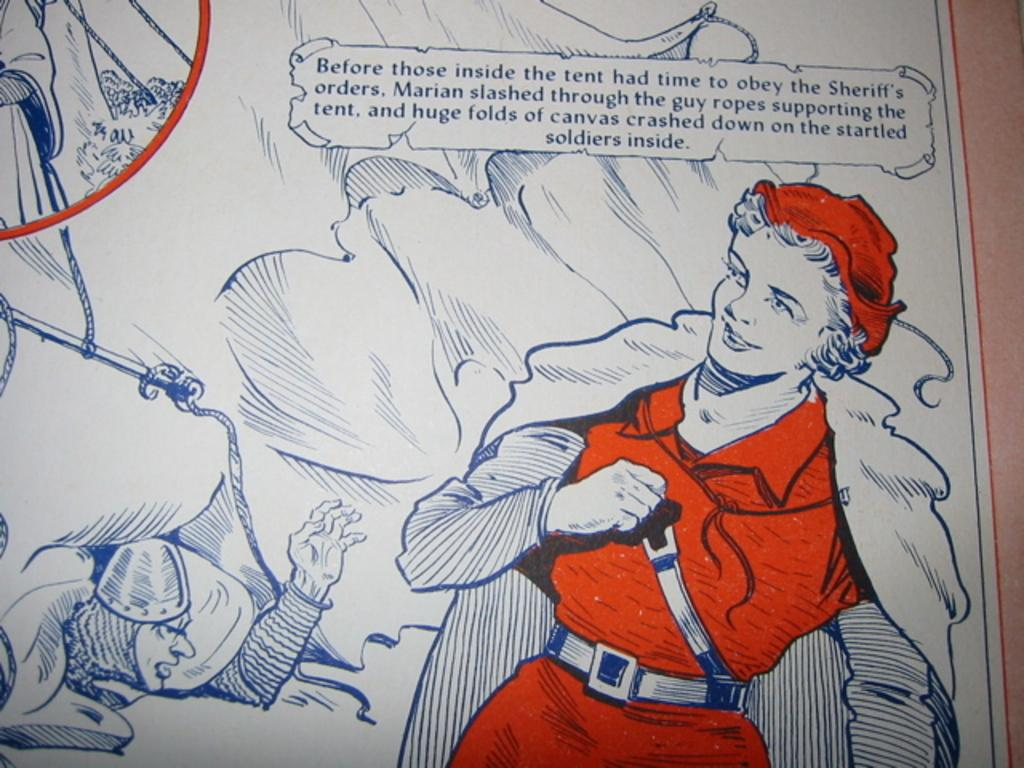<image>
Provide a brief description of the given image. A cartoon of a woman which has the words 'before those inside' to the top left. 